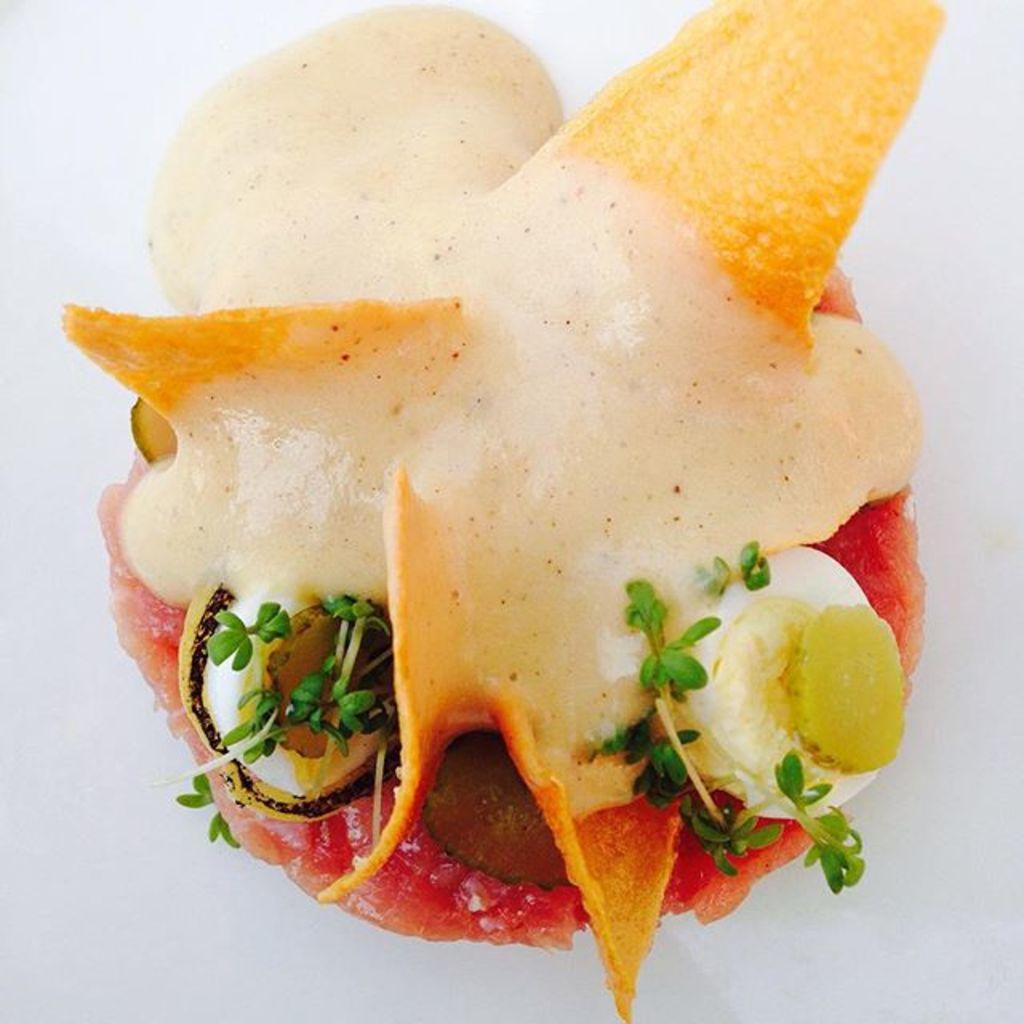Can you describe this image briefly? In this image I can see a food item on a white surface. On this food there are few leaves. 